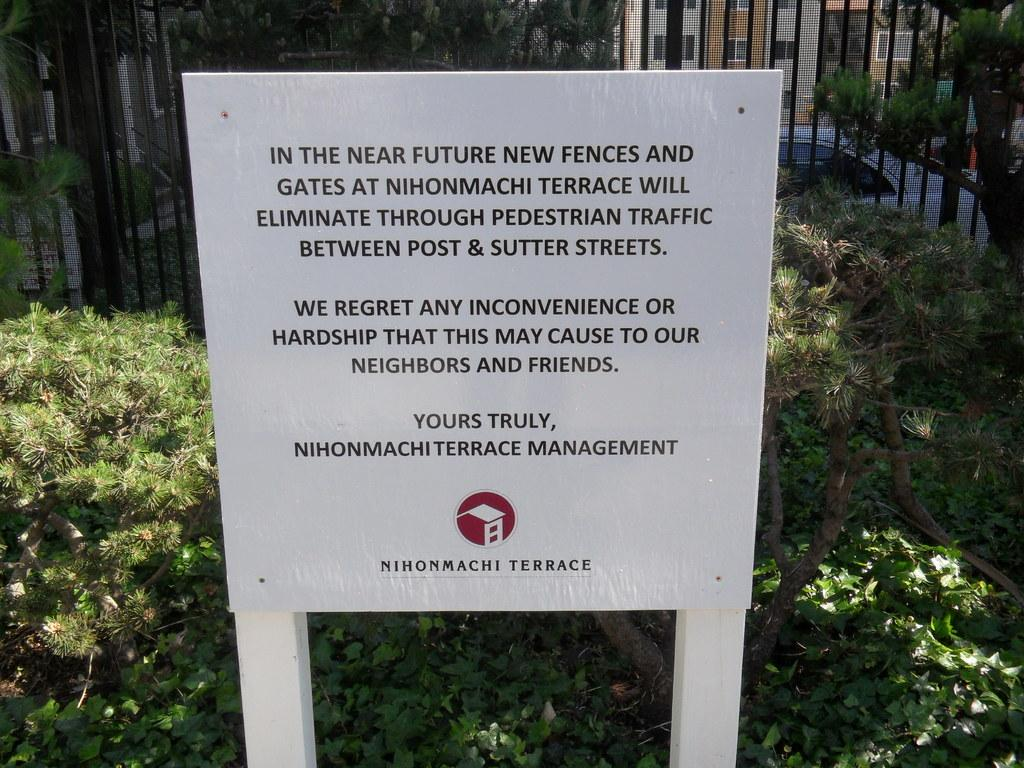What type of boat is in the image? There is a white boat in the image. What color are the plants visible in the image? The plants are green. What can be seen in the background of the image? There is a black iron grill in the background of the image. Where is the quince located in the image? There is no quince present in the image. What type of underwear is visible in the image? There is no underwear present in the image. 